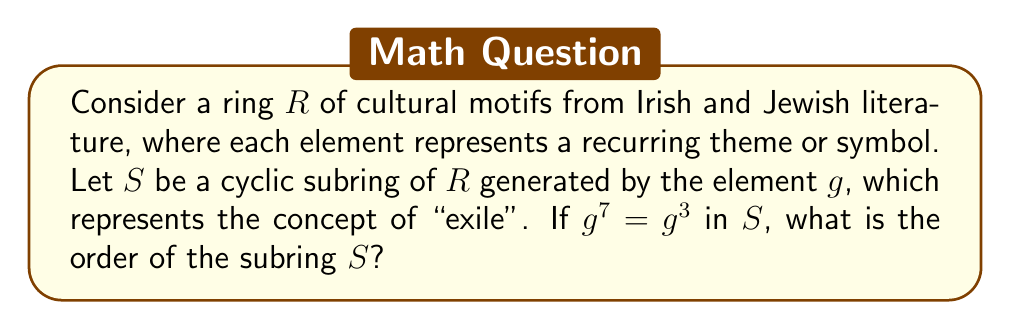Give your solution to this math problem. To solve this problem, we need to follow these steps:

1) In a cyclic subring $S$ generated by $g$, all elements have the form $g^n$ for some integer $n$.

2) The given condition $g^7 = g^3$ implies that $g^4 = e$, where $e$ is the identity element of the ring. This is because:

   $g^7 = g^3$
   $g^7 \cdot g^{-3} = g^3 \cdot g^{-3}$
   $g^4 = e$

3) This means that the powers of $g$ will start repeating after $g^4$:

   $g^0 = e$
   $g^1 = g$
   $g^2 = g^2$
   $g^3 = g^3$
   $g^4 = e$
   $g^5 = g$
   ...and so on

4) The order of a cyclic subring is the number of distinct elements it contains. From the pattern above, we can see that there are 4 distinct elements: $e$, $g$, $g^2$, and $g^3$.

5) Therefore, the order of the subring $S$ is 4.

This result is fitting for the given persona, as it could represent four distinct stages or themes of exile in Irish and Jewish literature: departure, wandering, longing, and return.
Answer: The order of the cyclic subring $S$ is 4. 